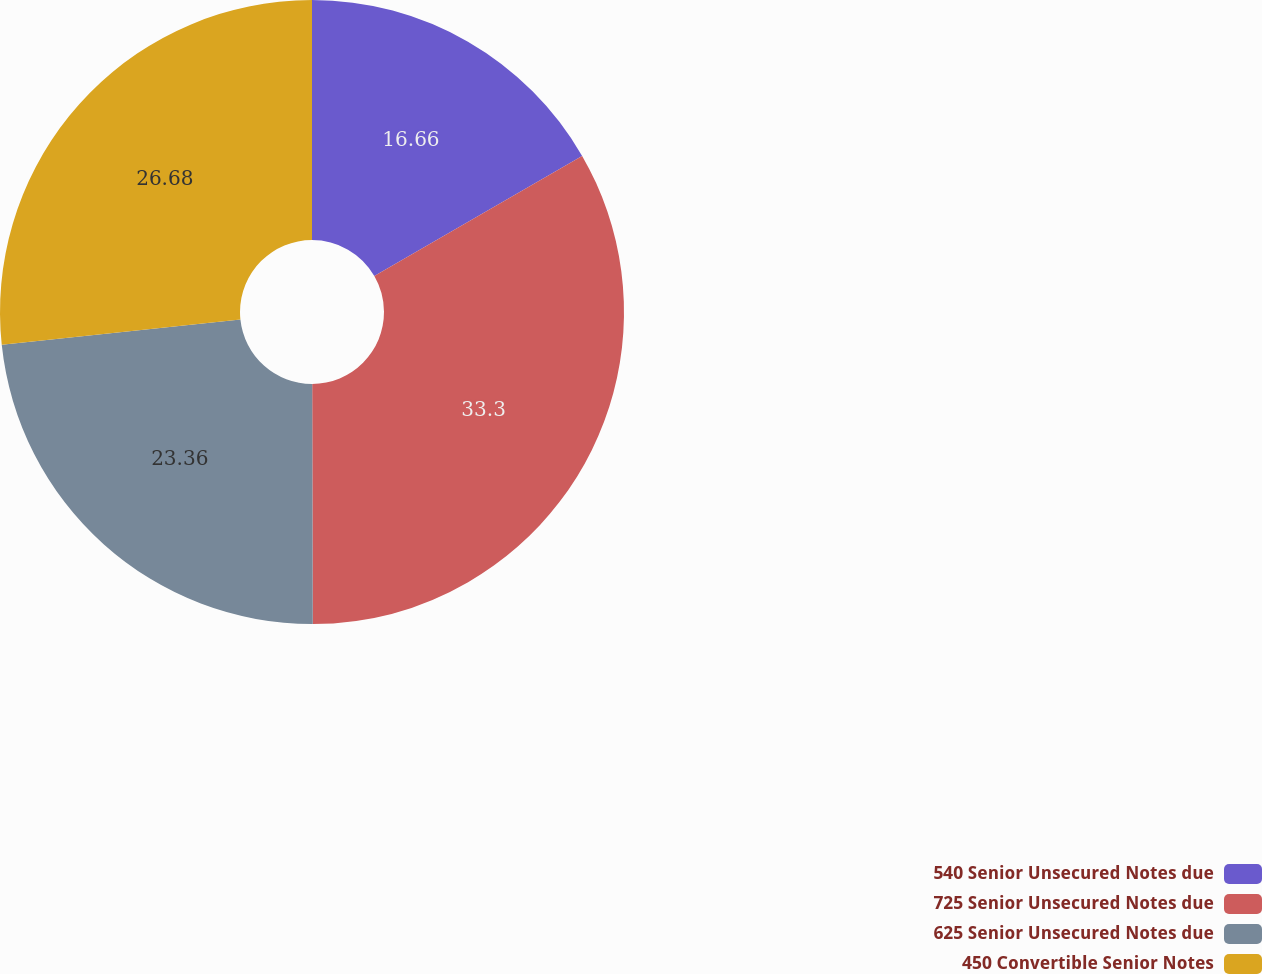<chart> <loc_0><loc_0><loc_500><loc_500><pie_chart><fcel>540 Senior Unsecured Notes due<fcel>725 Senior Unsecured Notes due<fcel>625 Senior Unsecured Notes due<fcel>450 Convertible Senior Notes<nl><fcel>16.66%<fcel>33.3%<fcel>23.36%<fcel>26.68%<nl></chart> 